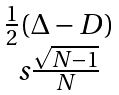<formula> <loc_0><loc_0><loc_500><loc_500>\begin{matrix} \frac { 1 } { 2 } ( \Delta - D ) \\ s \frac { \sqrt { N - 1 } } { N } \end{matrix}</formula> 